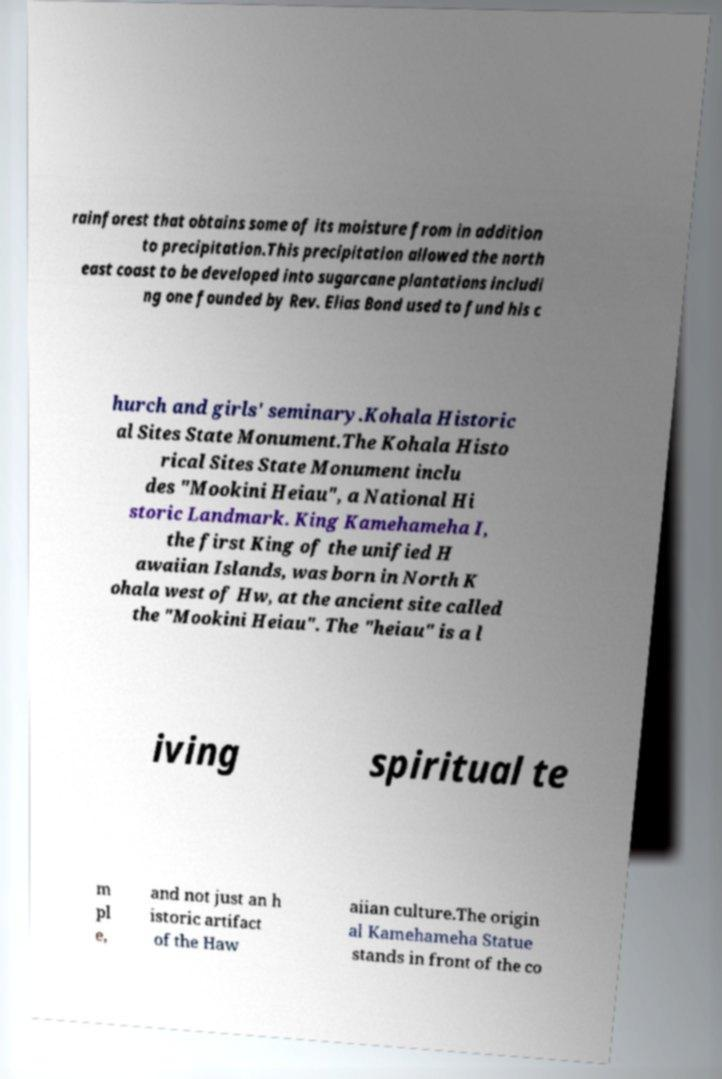Can you accurately transcribe the text from the provided image for me? rainforest that obtains some of its moisture from in addition to precipitation.This precipitation allowed the north east coast to be developed into sugarcane plantations includi ng one founded by Rev. Elias Bond used to fund his c hurch and girls' seminary.Kohala Historic al Sites State Monument.The Kohala Histo rical Sites State Monument inclu des "Mookini Heiau", a National Hi storic Landmark. King Kamehameha I, the first King of the unified H awaiian Islands, was born in North K ohala west of Hw, at the ancient site called the "Mookini Heiau". The "heiau" is a l iving spiritual te m pl e, and not just an h istoric artifact of the Haw aiian culture.The origin al Kamehameha Statue stands in front of the co 